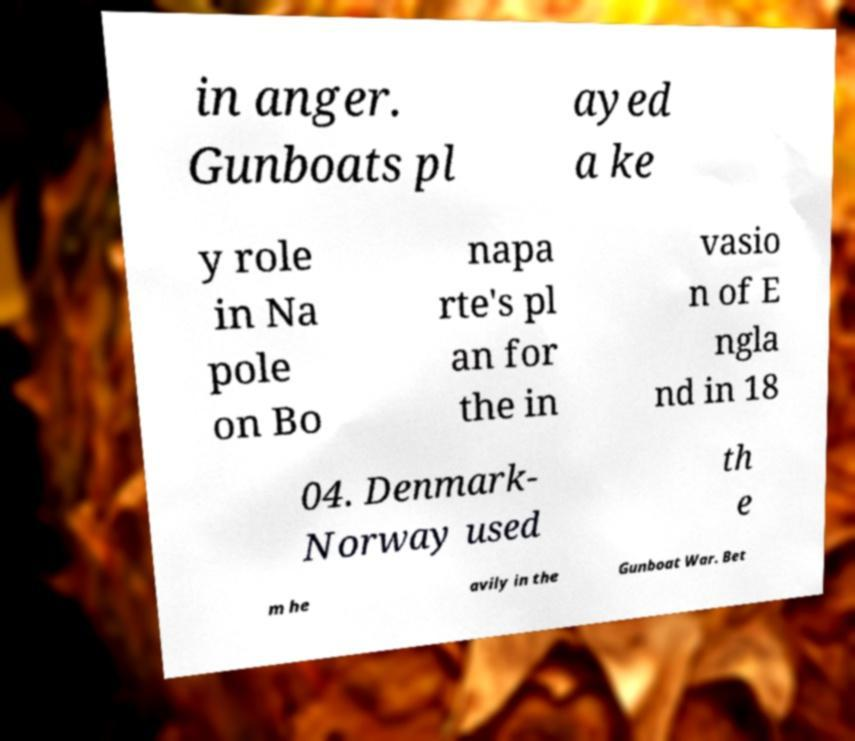Could you extract and type out the text from this image? in anger. Gunboats pl ayed a ke y role in Na pole on Bo napa rte's pl an for the in vasio n of E ngla nd in 18 04. Denmark- Norway used th e m he avily in the Gunboat War. Bet 